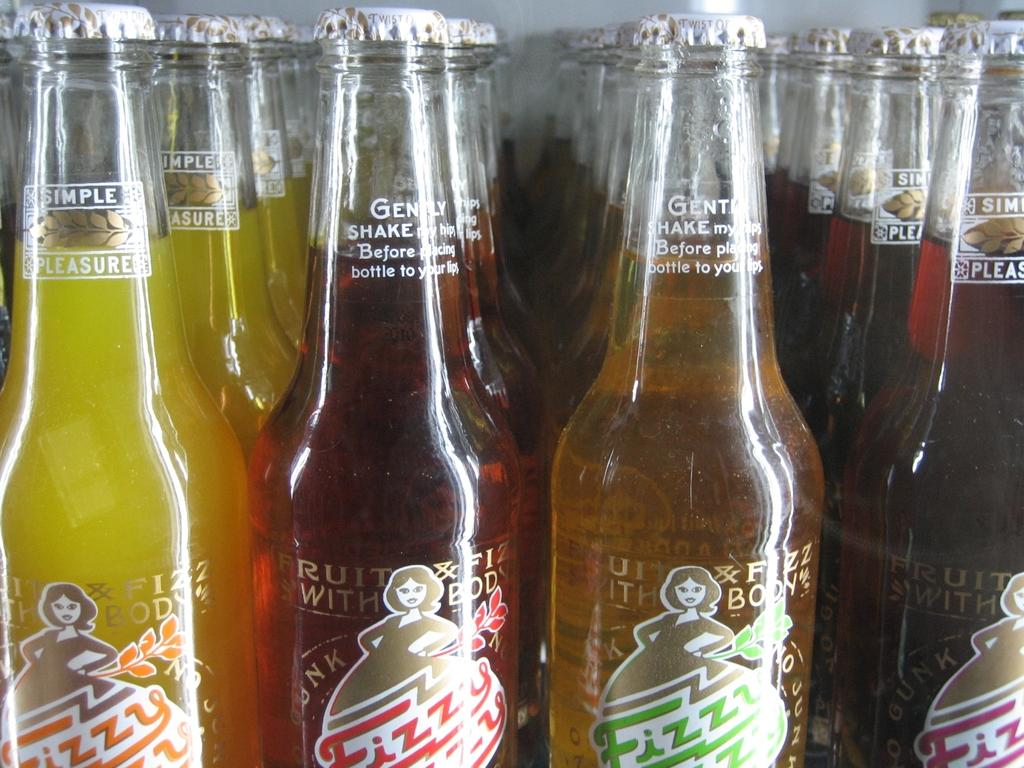<image>
Give a short and clear explanation of the subsequent image. four different colored bottles of Fizzy brand soda 